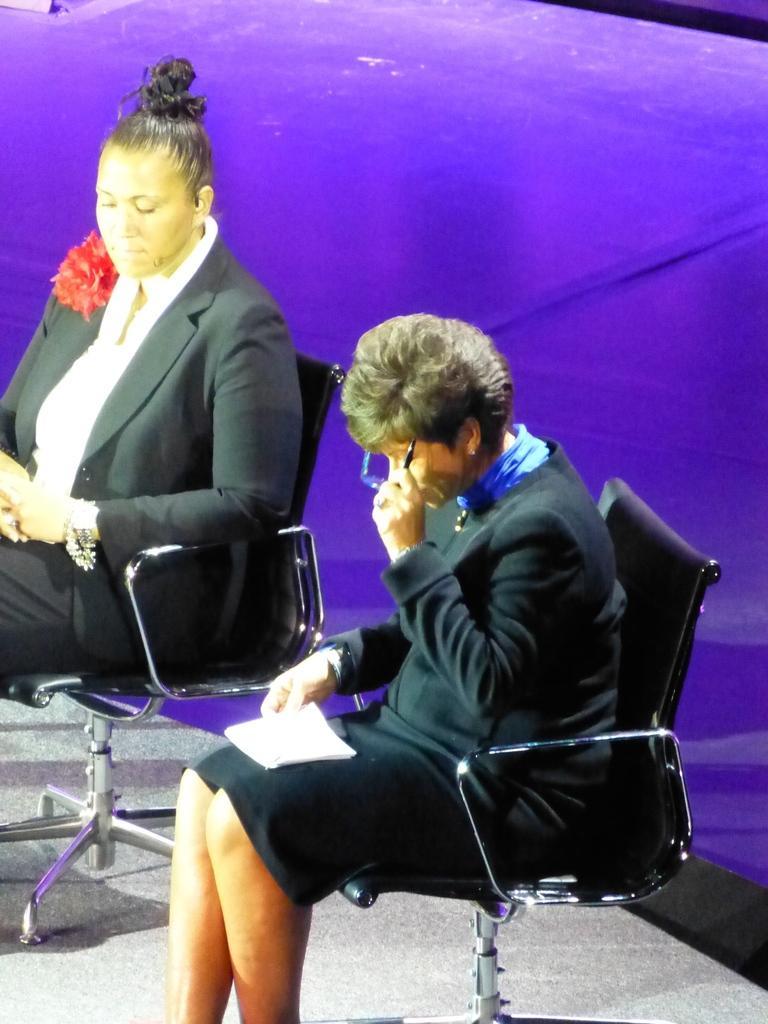Can you describe this image briefly? 2 people are sitting on the chairs wearing blazer. 